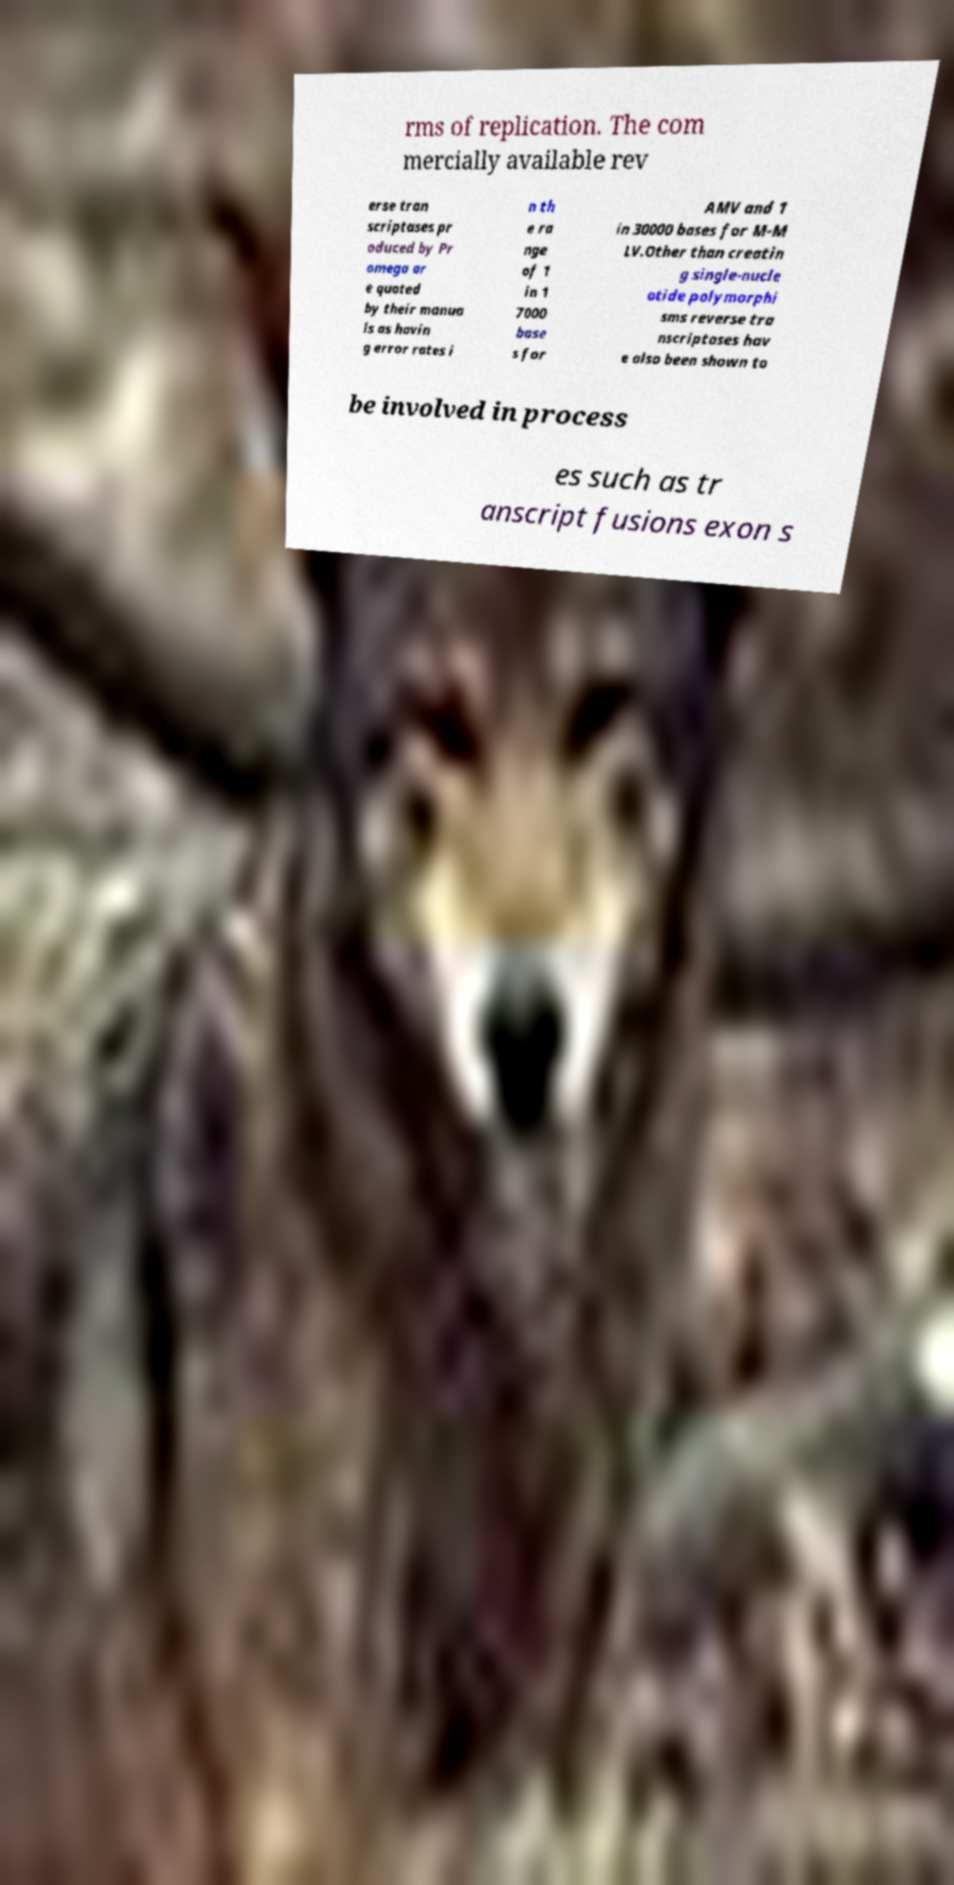Could you extract and type out the text from this image? rms of replication. The com mercially available rev erse tran scriptases pr oduced by Pr omega ar e quoted by their manua ls as havin g error rates i n th e ra nge of 1 in 1 7000 base s for AMV and 1 in 30000 bases for M-M LV.Other than creatin g single-nucle otide polymorphi sms reverse tra nscriptases hav e also been shown to be involved in process es such as tr anscript fusions exon s 